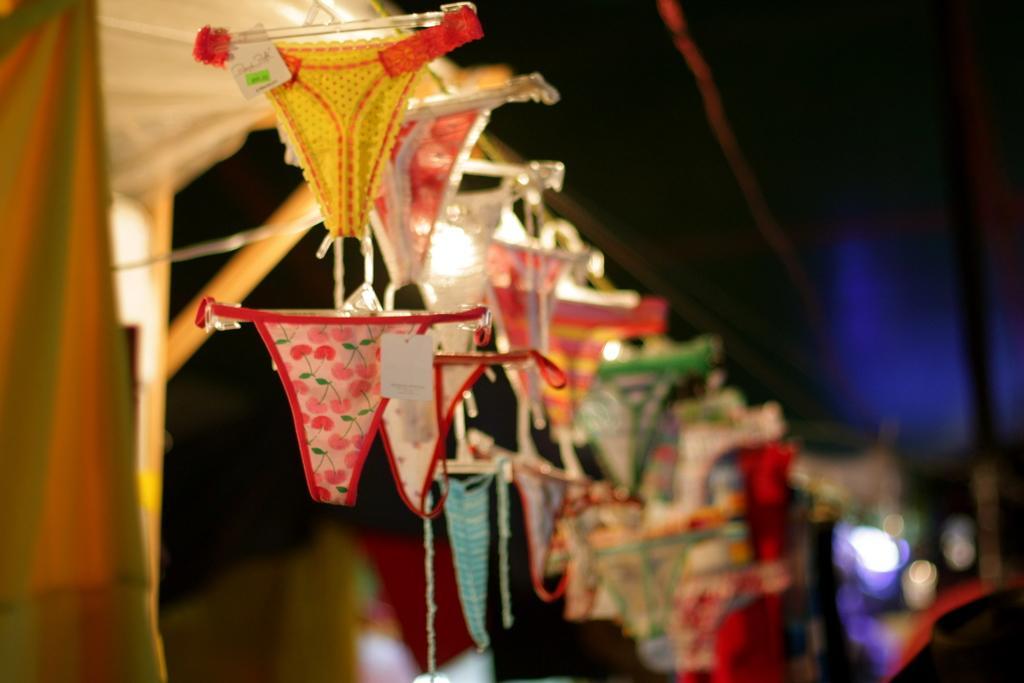Please provide a concise description of this image. In this image there are few clothes are on the hangers which are changed to a rod. Left side there is tent. Background is blurry. 